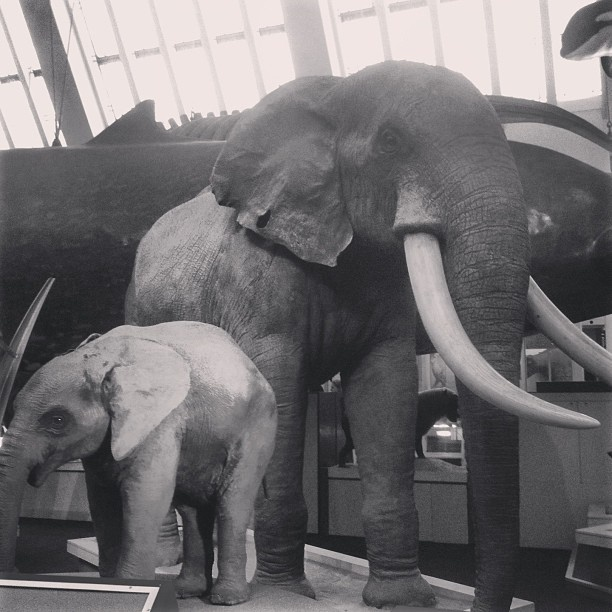Describe the objects in this image and their specific colors. I can see elephant in lightgray, gray, black, and darkgray tones and elephant in lightgray, gray, darkgray, and black tones in this image. 